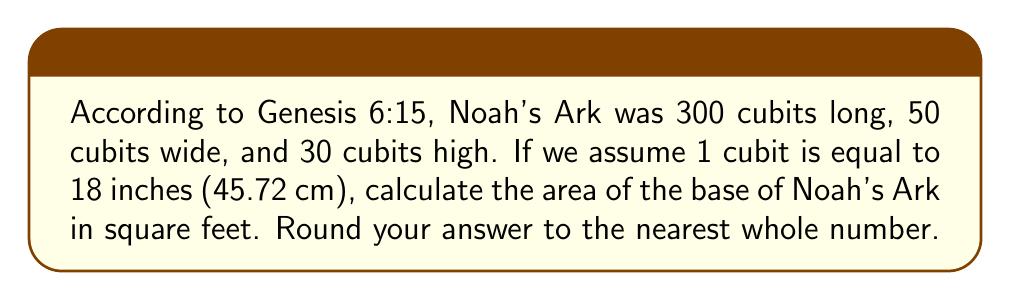Help me with this question. Let's approach this step-by-step:

1) First, we need to convert the dimensions from cubits to feet:
   
   Length: $300 \text{ cubits} \times \frac{18 \text{ inches}}{1 \text{ cubit}} \times \frac{1 \text{ foot}}{12 \text{ inches}} = 450 \text{ feet}$
   
   Width: $50 \text{ cubits} \times \frac{18 \text{ inches}}{1 \text{ cubit}} \times \frac{1 \text{ foot}}{12 \text{ inches}} = 75 \text{ feet}$

2) The base of Noah's Ark is rectangular. The area of a rectangle is given by the formula:

   $$ A = l \times w $$

   Where $A$ is the area, $l$ is the length, and $w$ is the width.

3) Substituting our values:

   $$ A = 450 \text{ feet} \times 75 \text{ feet} = 33,750 \text{ square feet} $$

4) The question asks for the answer rounded to the nearest whole number, but 33,750 is already a whole number, so no rounding is necessary.

Thus, the area of the base of Noah's Ark is 33,750 square feet.
Answer: 33,750 square feet 